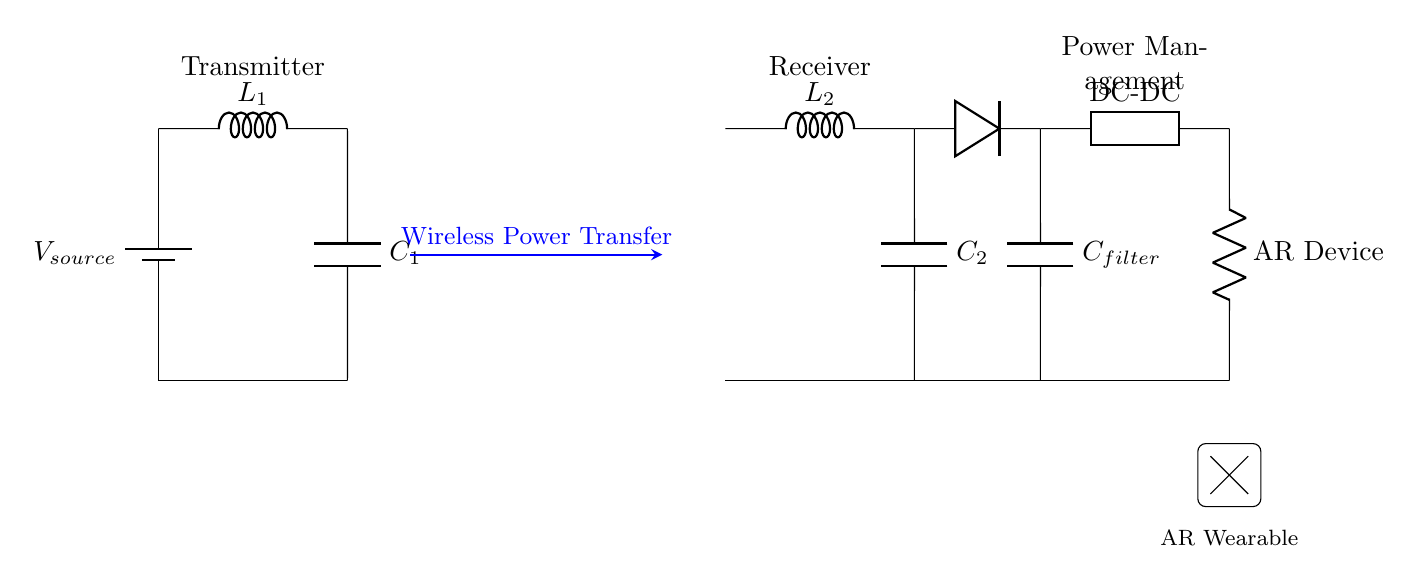What is the type of power source used in this circuit? The power source is a battery, as indicated by the component labeled "V_source" in the diagram.
Answer: battery How many inductors are in the circuit? There are two inductors in the circuit, labeled "L1" and "L2". This can be seen by the two components connected in series with the power transfer path.
Answer: 2 What component is used for rectification? The component used for rectification is a diode, which is identified in the circuit diagram by the symbol next to "L2". It converts AC to DC for the power management stage.
Answer: diode What is the purpose of the capacitor labeled "C_filter"? The capacitor labeled "C_filter" is used to smooth out the output voltage by filtering out ripples after rectification. This ensures a more stable supply to the load.
Answer: smoothing What is the role of the component labeled "DC-DC"? The "DC-DC" component functions as a converter to adjust the voltage levels to the appropriate specifications required by the AR device, ensuring compatibility and efficiency.
Answer: voltage adjustment What is the load connected to the power management section? The load connected to the power management section is the AR device, which is depicted in the diagram by the label "AR Device" near the resistor symbol.
Answer: AR Device What does the blue arrow in the diagram represent? The blue arrow represents the "Wireless Power Transfer" method used to transmit energy from the transmitter to the receiver wirelessly, emphasizing the innovative aspect of the circuit design.
Answer: Wireless Power Transfer 